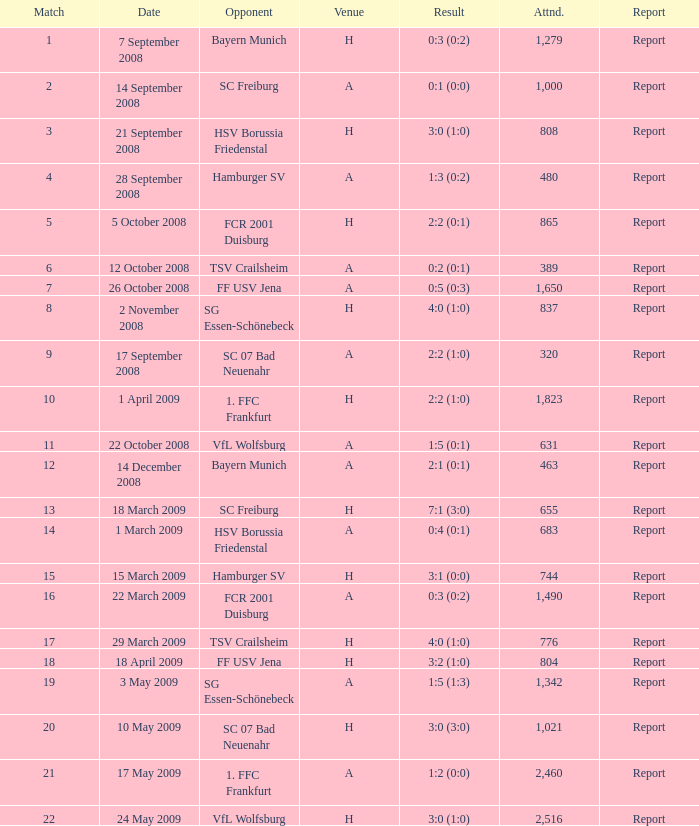What is the match number that had a result of 0:5 (0:3)? 1.0. 